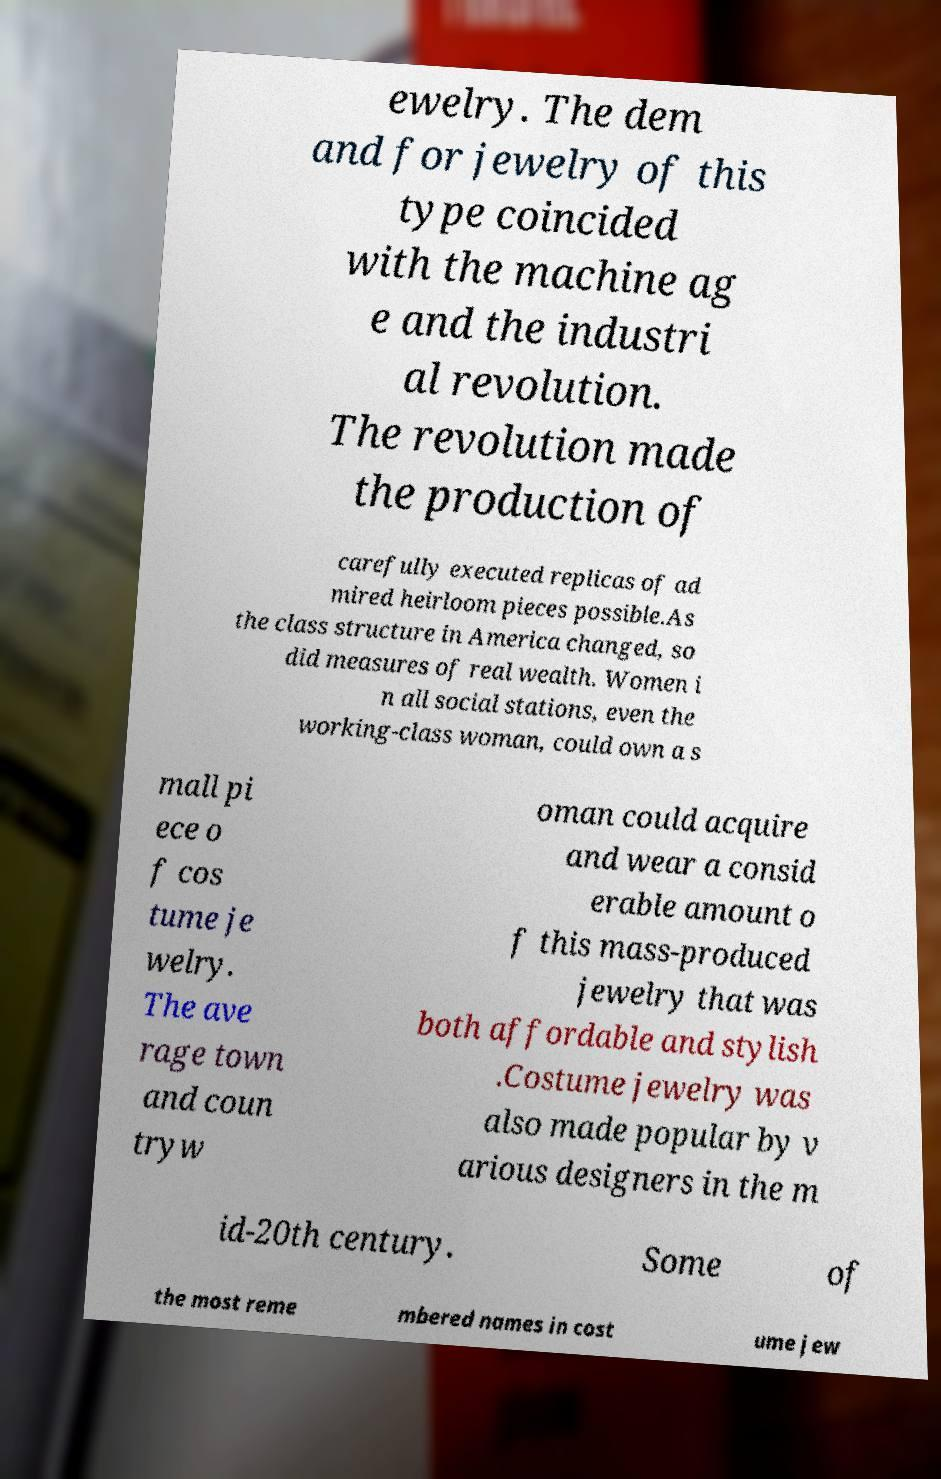I need the written content from this picture converted into text. Can you do that? ewelry. The dem and for jewelry of this type coincided with the machine ag e and the industri al revolution. The revolution made the production of carefully executed replicas of ad mired heirloom pieces possible.As the class structure in America changed, so did measures of real wealth. Women i n all social stations, even the working-class woman, could own a s mall pi ece o f cos tume je welry. The ave rage town and coun tryw oman could acquire and wear a consid erable amount o f this mass-produced jewelry that was both affordable and stylish .Costume jewelry was also made popular by v arious designers in the m id-20th century. Some of the most reme mbered names in cost ume jew 